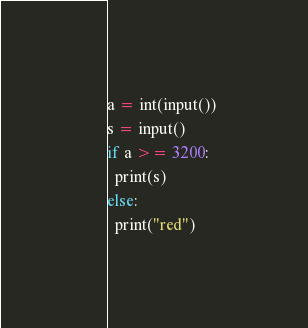<code> <loc_0><loc_0><loc_500><loc_500><_Python_>a = int(input())
s = input()
if a >= 3200:
  print(s)
else:
  print("red")</code> 